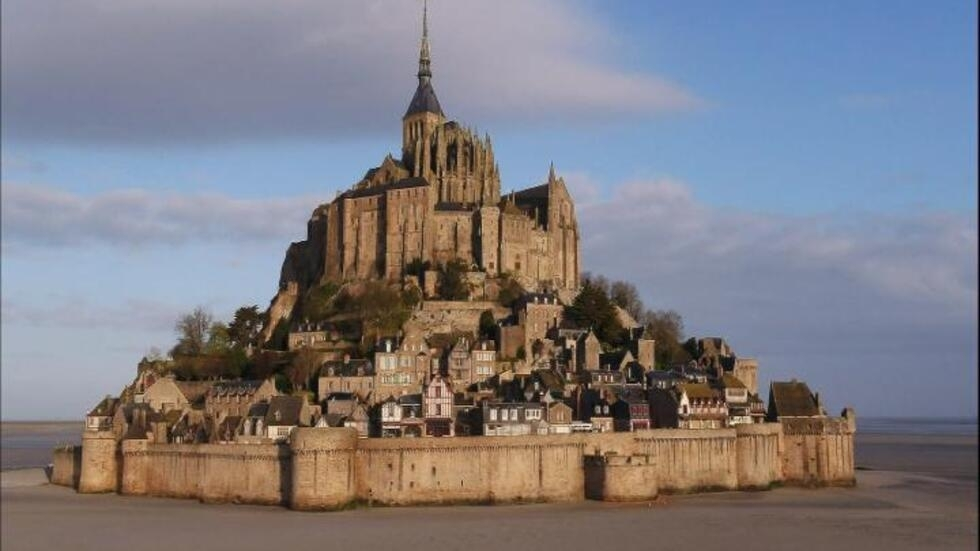Could you describe the historical significance of this place? Mont Saint Michel has a rich history dating back to the 8th century when it was first established as a small church by a bishop named Aubert. It quickly became an important pilgrimage site and was developed into the grand abbey seen today. Over the centuries, it has witnessed numerous battles and sieges, standing resilient as a fortress during the Hundred Years' War. Its unique position as an island made it a strategic military stronghold. What's the architectural style of the abbey in the image? The abbey of Mont Saint Michel showcases a blend of Romanesque and Gothic architectural styles. The lower parts of the abbey feature Romanesque design, characterized by rounded arches and sturdy pillars. As you move upward, the style transitions to Gothic, evident in the pointed arches, ribbed vaults, and flying buttresses. The tall spire crowning the structure exemplifies the gothic aspiration towards reaching the heavens. 